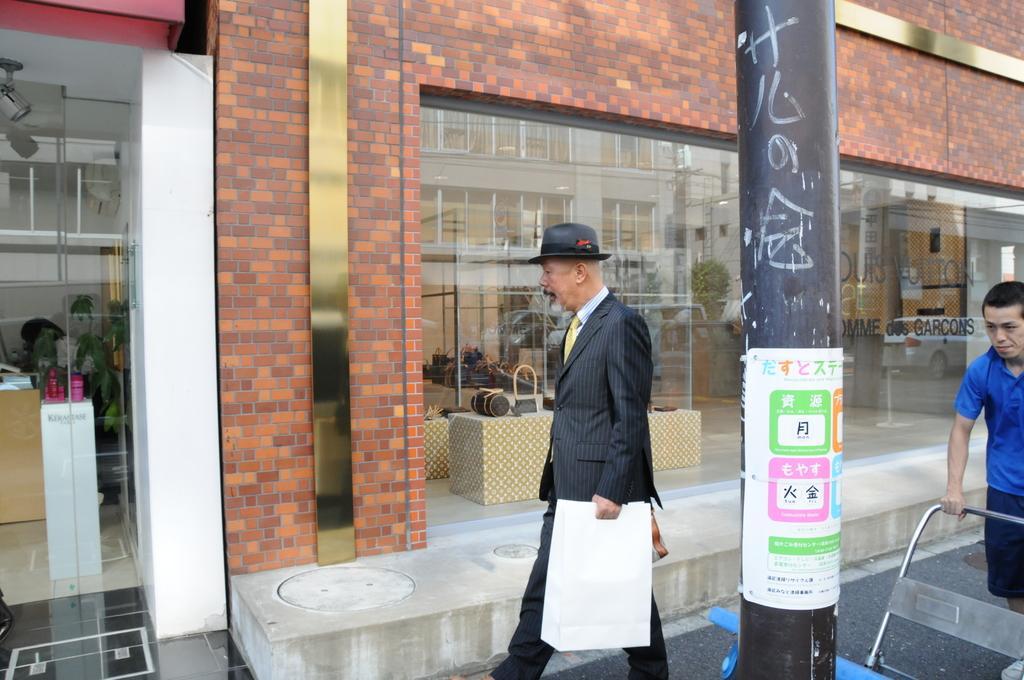In one or two sentences, can you explain what this image depicts? In this picture we can see two persons walking here, in the background there is a building, we can see a glass here, in the front there is a pole, we can see papers pasted on the pole, this man is carrying a bag. 